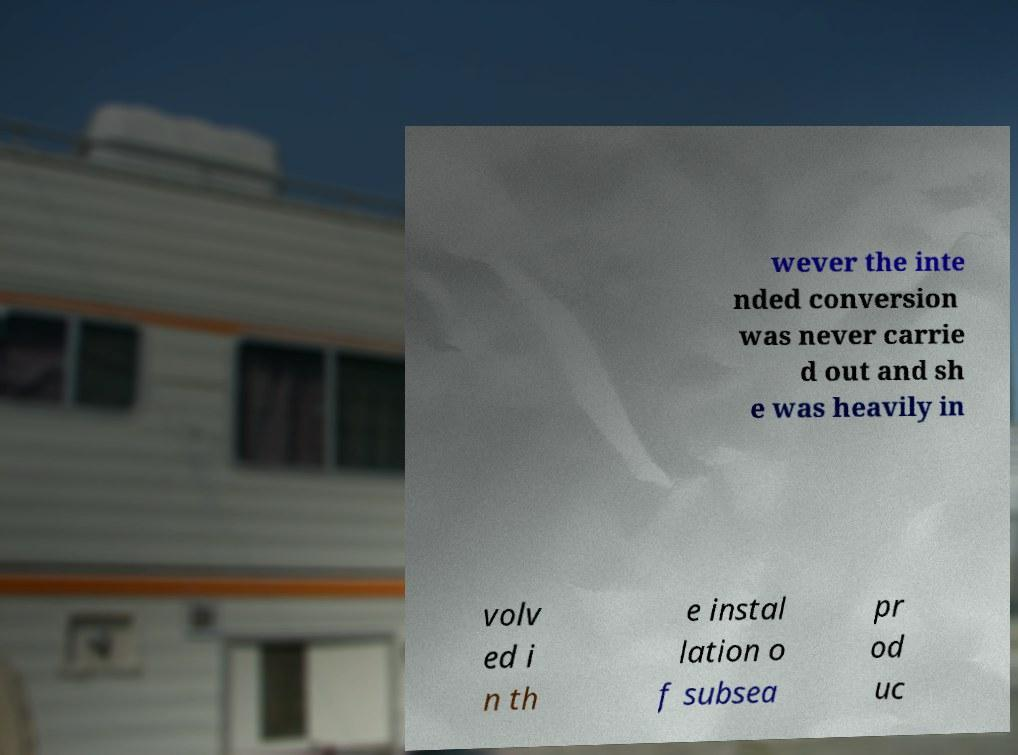Can you accurately transcribe the text from the provided image for me? wever the inte nded conversion was never carrie d out and sh e was heavily in volv ed i n th e instal lation o f subsea pr od uc 